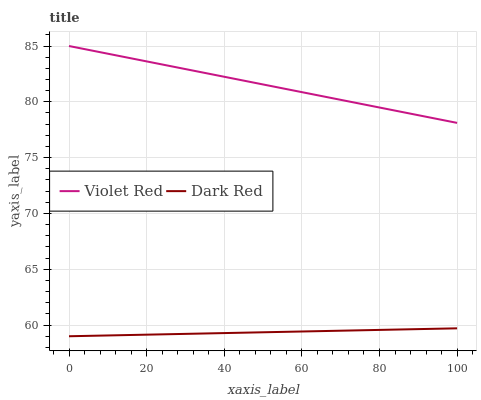Does Dark Red have the minimum area under the curve?
Answer yes or no. Yes. Does Violet Red have the maximum area under the curve?
Answer yes or no. Yes. Does Violet Red have the minimum area under the curve?
Answer yes or no. No. Is Dark Red the smoothest?
Answer yes or no. Yes. Is Violet Red the roughest?
Answer yes or no. Yes. Is Violet Red the smoothest?
Answer yes or no. No. Does Dark Red have the lowest value?
Answer yes or no. Yes. Does Violet Red have the lowest value?
Answer yes or no. No. Does Violet Red have the highest value?
Answer yes or no. Yes. Is Dark Red less than Violet Red?
Answer yes or no. Yes. Is Violet Red greater than Dark Red?
Answer yes or no. Yes. Does Dark Red intersect Violet Red?
Answer yes or no. No. 